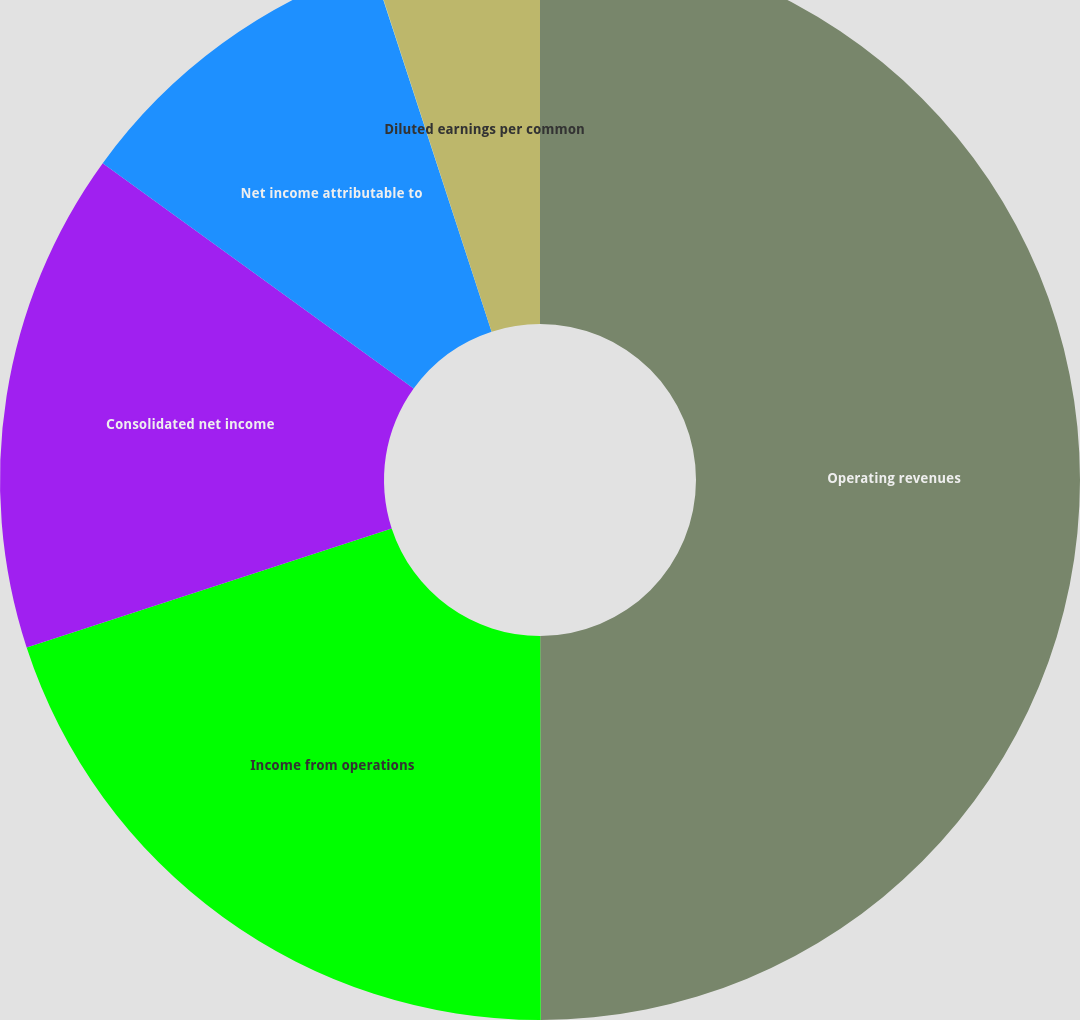<chart> <loc_0><loc_0><loc_500><loc_500><pie_chart><fcel>Operating revenues<fcel>Income from operations<fcel>Consolidated net income<fcel>Net income attributable to<fcel>Basic earnings per common<fcel>Diluted earnings per common<nl><fcel>49.98%<fcel>20.0%<fcel>15.0%<fcel>10.0%<fcel>0.01%<fcel>5.01%<nl></chart> 